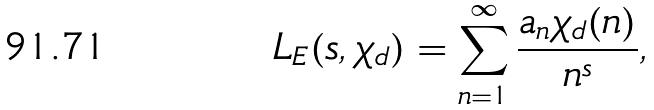<formula> <loc_0><loc_0><loc_500><loc_500>L _ { E } ( s , \chi _ { d } ) = \sum _ { n = 1 } ^ { \infty } \frac { a _ { n } \chi _ { d } ( n ) } { n ^ { s } } ,</formula> 